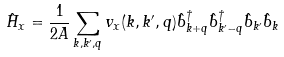Convert formula to latex. <formula><loc_0><loc_0><loc_500><loc_500>\hat { H } _ { x } = \frac { 1 } { 2 A } \sum _ { { k } , { k ^ { \prime } } , { q } } v _ { x } ( { k } , { k ^ { \prime } } , { q } ) \hat { b } ^ { \dag } _ { { k } + { q } } \hat { b } ^ { \dag } _ { { k ^ { \prime } } - { q } } \hat { b } _ { k ^ { \prime } } \hat { b } _ { k } \,</formula> 